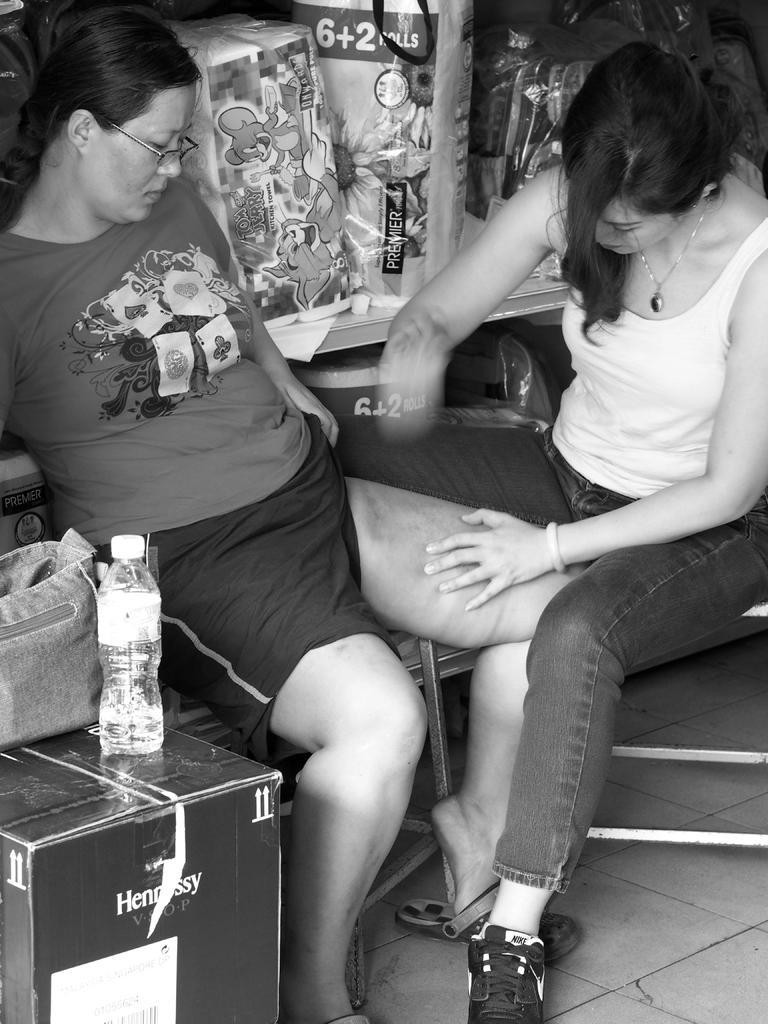Describe this image in one or two sentences. In this picture we can see two woman, the right side woman is holding left side woman's leg, in front of them we can see a bottle, bag on the box. 